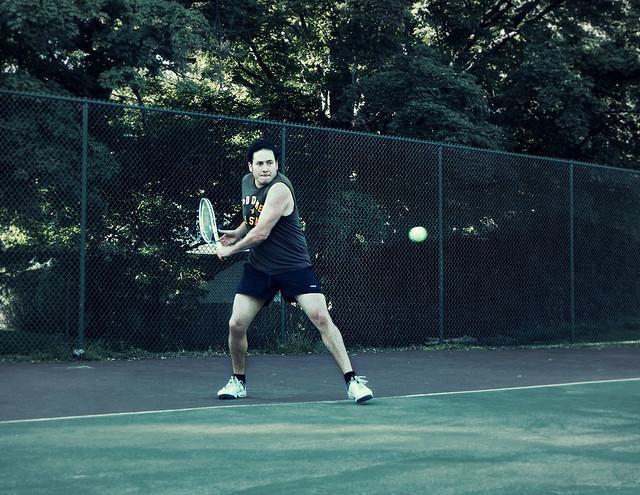How many people can you see?
Give a very brief answer. 1. How many bikes are below the outdoor wall decorations?
Give a very brief answer. 0. 